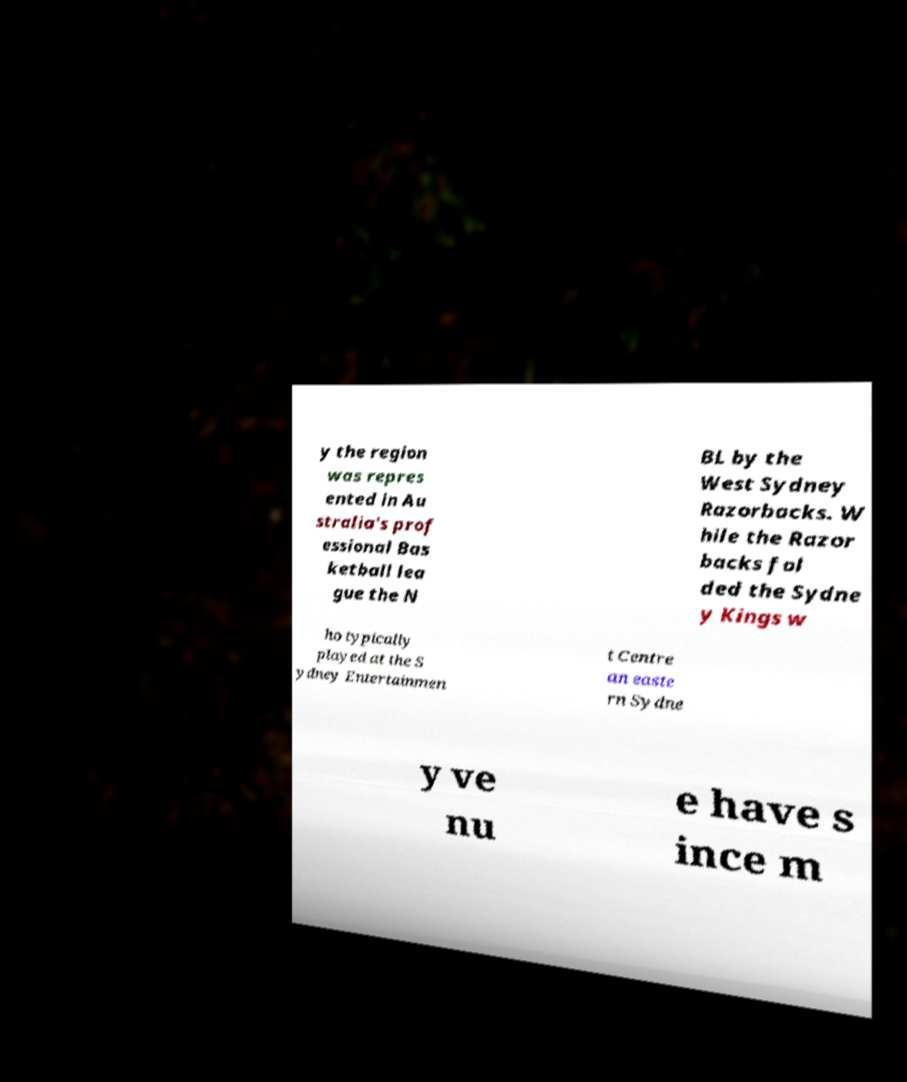Please identify and transcribe the text found in this image. y the region was repres ented in Au stralia's prof essional Bas ketball lea gue the N BL by the West Sydney Razorbacks. W hile the Razor backs fol ded the Sydne y Kings w ho typically played at the S ydney Entertainmen t Centre an easte rn Sydne y ve nu e have s ince m 